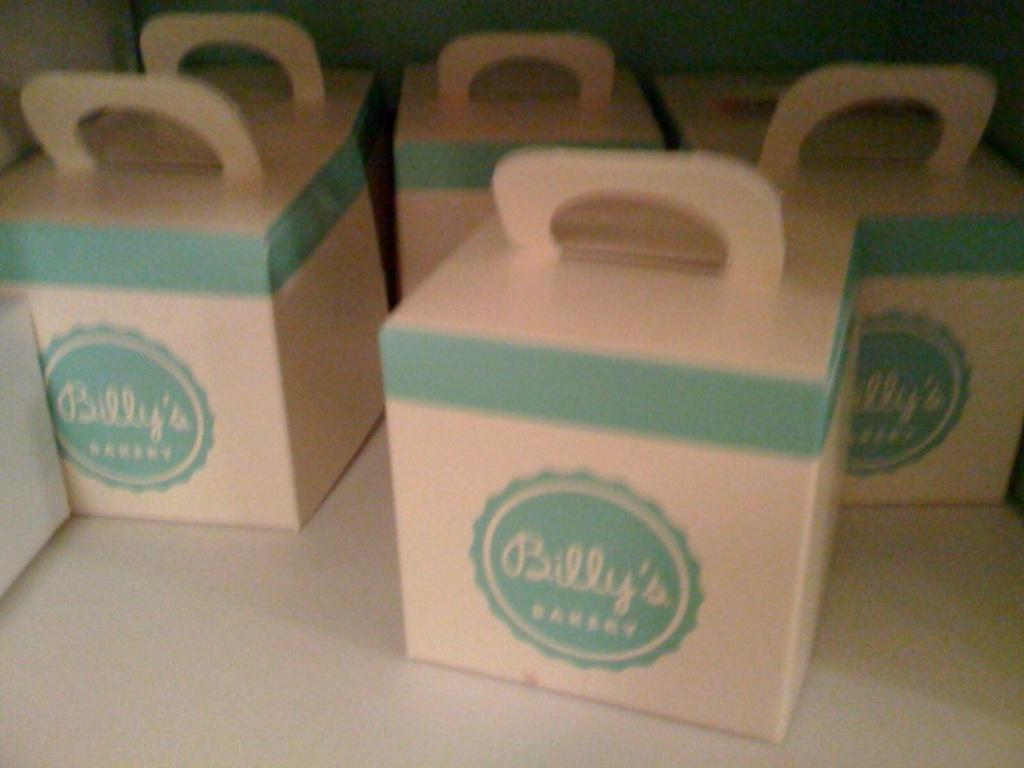<image>
Summarize the visual content of the image. multiple Billy's Bakery take out boxes with handles 